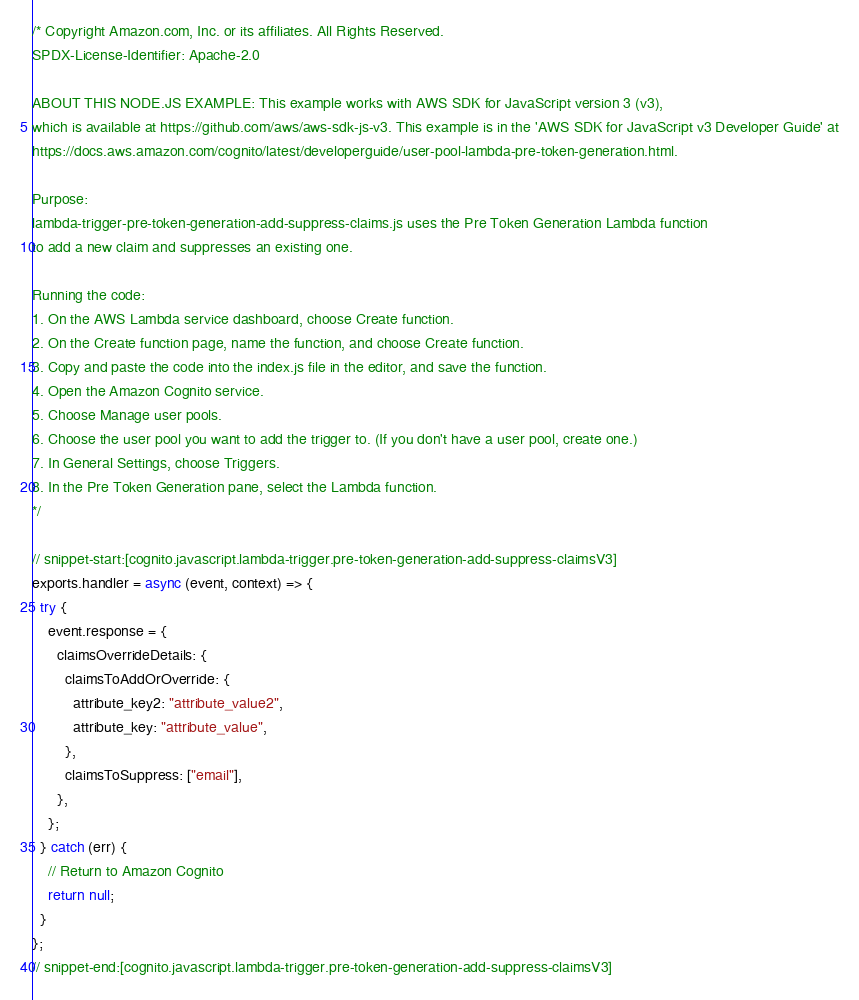Convert code to text. <code><loc_0><loc_0><loc_500><loc_500><_JavaScript_>/* Copyright Amazon.com, Inc. or its affiliates. All Rights Reserved.
SPDX-License-Identifier: Apache-2.0

ABOUT THIS NODE.JS EXAMPLE: This example works with AWS SDK for JavaScript version 3 (v3),
which is available at https://github.com/aws/aws-sdk-js-v3. This example is in the 'AWS SDK for JavaScript v3 Developer Guide' at
https://docs.aws.amazon.com/cognito/latest/developerguide/user-pool-lambda-pre-token-generation.html.

Purpose:
lambda-trigger-pre-token-generation-add-suppress-claims.js uses the Pre Token Generation Lambda function
to add a new claim and suppresses an existing one.

Running the code:
1. On the AWS Lambda service dashboard, choose Create function.
2. On the Create function page, name the function, and choose Create function.
3. Copy and paste the code into the index.js file in the editor, and save the function.
4. Open the Amazon Cognito service.
5. Choose Manage user pools.
6. Choose the user pool you want to add the trigger to. (If you don't have a user pool, create one.)
7. In General Settings, choose Triggers.
8. In the Pre Token Generation pane, select the Lambda function.
*/

// snippet-start:[cognito.javascript.lambda-trigger.pre-token-generation-add-suppress-claimsV3]
exports.handler = async (event, context) => {
  try {
    event.response = {
      claimsOverrideDetails: {
        claimsToAddOrOverride: {
          attribute_key2: "attribute_value2",
          attribute_key: "attribute_value",
        },
        claimsToSuppress: ["email"],
      },
    };
  } catch (err) {
    // Return to Amazon Cognito
    return null;
  }
};
// snippet-end:[cognito.javascript.lambda-trigger.pre-token-generation-add-suppress-claimsV3]
</code> 